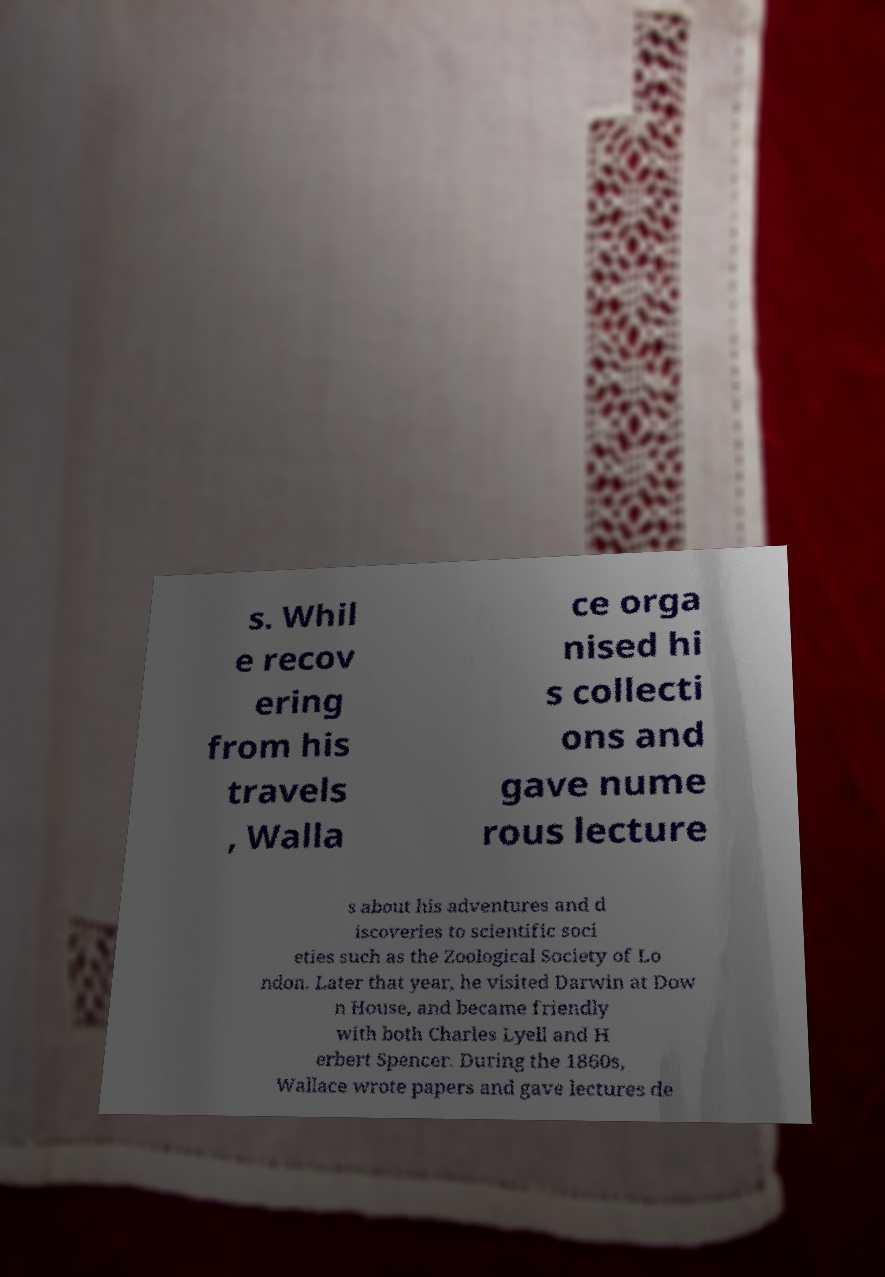Can you read and provide the text displayed in the image?This photo seems to have some interesting text. Can you extract and type it out for me? s. Whil e recov ering from his travels , Walla ce orga nised hi s collecti ons and gave nume rous lecture s about his adventures and d iscoveries to scientific soci eties such as the Zoological Society of Lo ndon. Later that year, he visited Darwin at Dow n House, and became friendly with both Charles Lyell and H erbert Spencer. During the 1860s, Wallace wrote papers and gave lectures de 